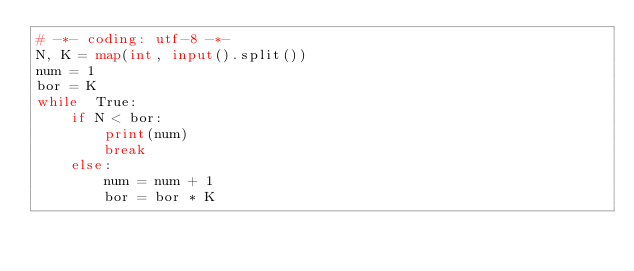<code> <loc_0><loc_0><loc_500><loc_500><_Python_># -*- coding: utf-8 -*-
N, K = map(int, input().split())
num = 1
bor = K
while  True:
    if N < bor:
        print(num)
        break
    else:
        num = num + 1
        bor = bor * K</code> 